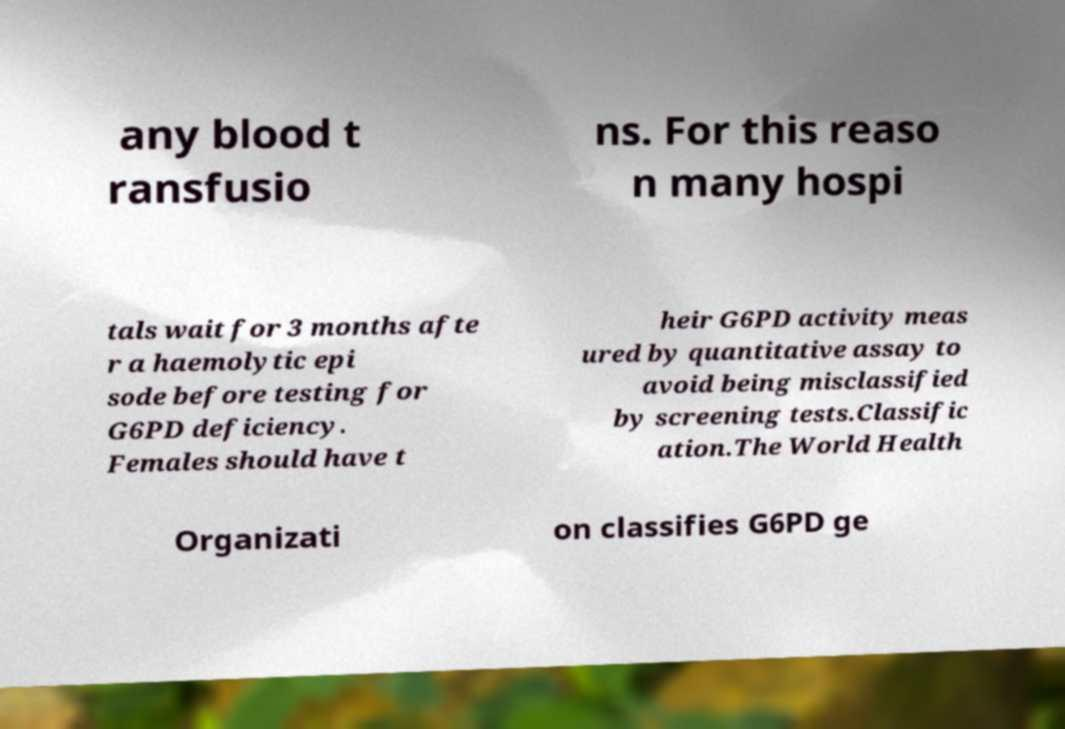What messages or text are displayed in this image? I need them in a readable, typed format. any blood t ransfusio ns. For this reaso n many hospi tals wait for 3 months afte r a haemolytic epi sode before testing for G6PD deficiency. Females should have t heir G6PD activity meas ured by quantitative assay to avoid being misclassified by screening tests.Classific ation.The World Health Organizati on classifies G6PD ge 